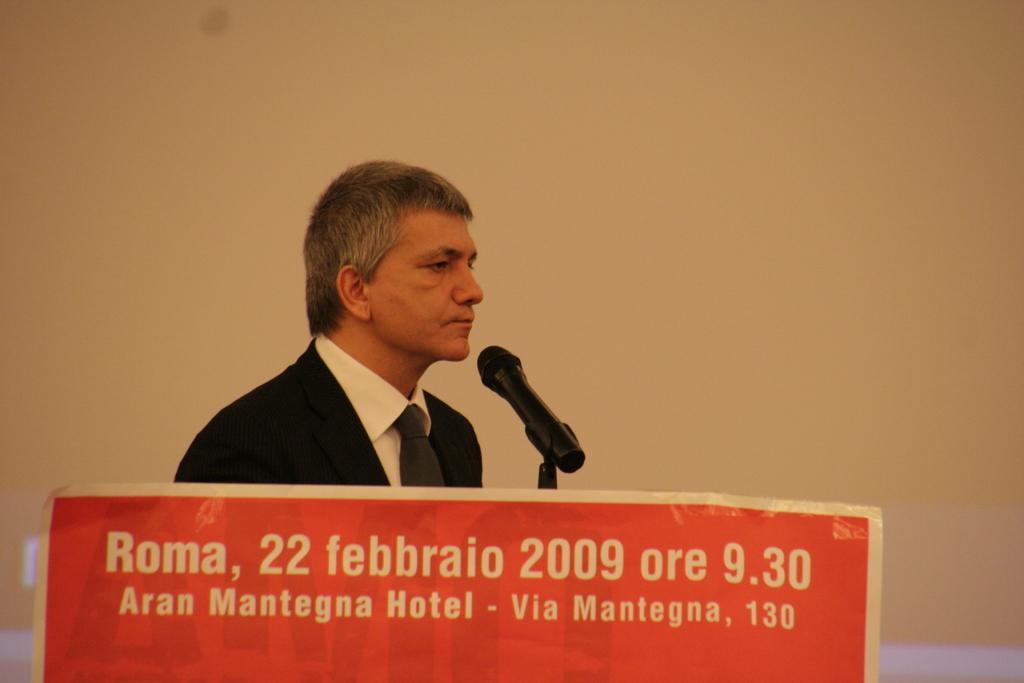In one or two sentences, can you explain what this image depicts? In the background we can see the wall painted with the cream paint. In this picture we can see a man wearing a tie, shirt, blazer. We can see a microphone. At the bottom portion of the picture we can see a poster with some information. 